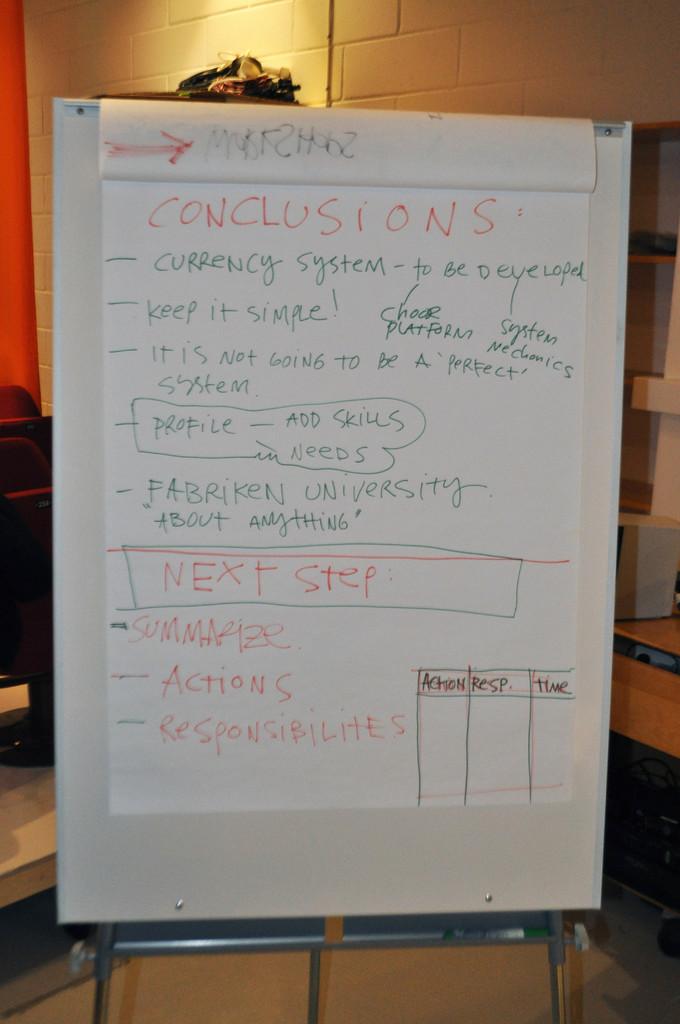What conclusions do we have?
Keep it short and to the point. Currenty system, keep it simple! , it is not going to be a 'perfect' system. 